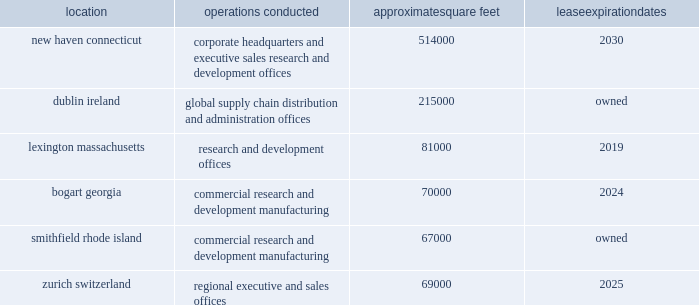Item 2 .
Properties .
We conduct our primary operations at the owned and leased facilities described below .
Location operations conducted approximate square feet expiration new haven , connecticut corporate headquarters and executive , sales , research and development offices 514000 .
We believe that our administrative office space is adequate to meet our needs for the foreseeable future .
We also believe that our research and development facilities and our manufacturing facility , together with third party manufacturing facilities , will be adequate for our on-going activities .
In addition to the locations above , we also lease space in other u.s .
Locations and in foreign countries to support our operations as a global organization .
As of december 31 , 2015 , we also leased approximately 254000 square feet in cheshire , connecticut , which was the previous location of our corporate headquarters and executive , sales , research and development offices .
In december 2015 , we entered into an early termination of this lease and will occupy this space through may 2016 .
In april 2014 , we purchased a fill/finish facility in athlone , ireland .
Following refurbishment of the facility , and after successful completion of the appropriate validation processes and regulatory approvals , the facility will become our first company-owned fill/finish and packaging facility for our commercial and clinical products .
In may 2015 , we announced plans to construct a new biologics manufacturing facility on our existing property in dublin ireland , which is expected to be completed by 2020 .
Item 3 .
Legal proceedings .
In may 2015 , we received a subpoena in connection with an investigation by the enforcement division of the sec requesting information related to our grant-making activities and compliance with the fcpa in various countries .
The sec also seeks information related to alexion 2019s recalls of specific lots of soliris and related securities disclosures .
In addition , in october 2015 , alexion received a request from the doj for the voluntary production of documents and other information pertaining to alexion's compliance with the fcpa .
Alexion is cooperating with these investigations .
At this time , alexion is unable to predict the duration , scope or outcome of these investigations .
Given the ongoing nature of these investigations , management does not currently believe a loss related to these matters is probable or that the potential magnitude of such loss or range of loss , if any , can be reasonably estimated .
Item 4 .
Mine safety disclosures .
Not applicable. .
How many square feet are owned by alexion pharmaceuticals , inc? 
Computations: (215000 + 67000)
Answer: 282000.0. 